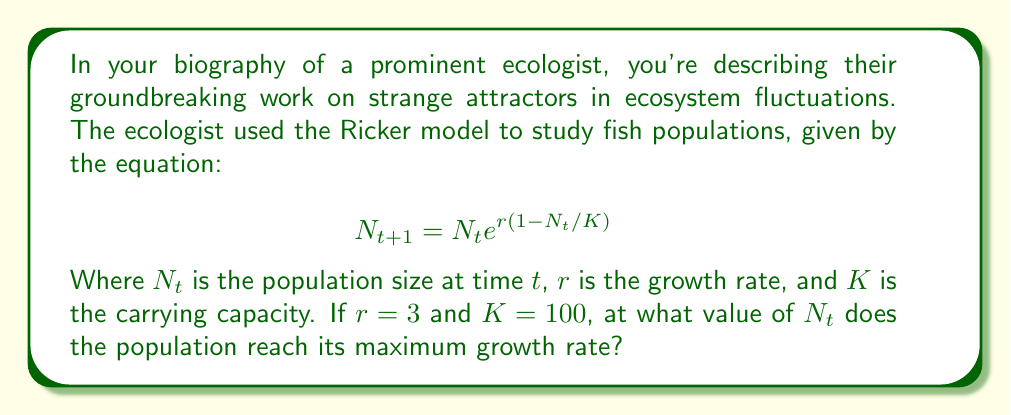Could you help me with this problem? To find the maximum growth rate, we need to follow these steps:

1) First, let's rewrite the equation in terms of the growth rate:

   $$\frac{N_{t+1}}{N_t} = e^{r(1-N_t/K)}$$

2) To find the maximum, we need to differentiate this with respect to $N_t$ and set it to zero:

   $$\frac{d}{dN_t}\left(e^{r(1-N_t/K)}\right) = e^{r(1-N_t/K)} \cdot \frac{d}{dN_t}\left(r(1-N_t/K)\right) = 0$$

3) Simplifying:

   $$e^{r(1-N_t/K)} \cdot \left(-\frac{r}{K}\right) = 0$$

4) Since $e^x$ is always positive, this equation is satisfied when:

   $$-\frac{r}{K} = 0$$

   Which is never true for positive $r$ and $K$.

5) This means the maximum occurs at an inflection point. To find this, we need to set the second derivative to zero:

   $$\frac{d^2}{dN_t^2}\left(e^{r(1-N_t/K)}\right) = e^{r(1-N_t/K)} \cdot \left(-\frac{r}{K}\right)^2 - e^{r(1-N_t/K)} \cdot \left(-\frac{r}{K}\right) = 0$$

6) Simplifying:

   $$e^{r(1-N_t/K)} \cdot \left(-\frac{r}{K}\right) \cdot \left(\frac{r}{K} - 1\right) = 0$$

7) This is satisfied when:

   $$\frac{r}{K} - 1 = 0$$
   $$\frac{r}{K} = 1$$
   $$N_t = K$$

8) Substituting the given values $r = 3$ and $K = 100$:

   $$N_t = 100$$

Therefore, the population reaches its maximum growth rate when $N_t = 100$.
Answer: 100 